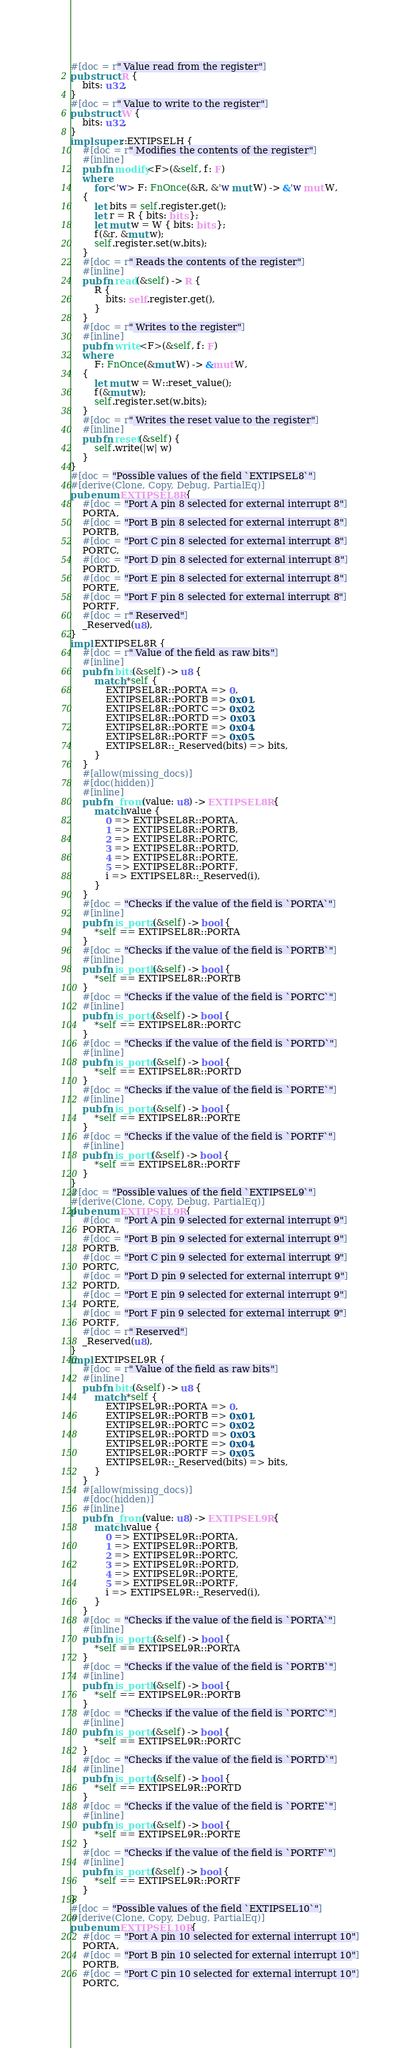Convert code to text. <code><loc_0><loc_0><loc_500><loc_500><_Rust_>#[doc = r" Value read from the register"]
pub struct R {
    bits: u32,
}
#[doc = r" Value to write to the register"]
pub struct W {
    bits: u32,
}
impl super::EXTIPSELH {
    #[doc = r" Modifies the contents of the register"]
    #[inline]
    pub fn modify<F>(&self, f: F)
    where
        for<'w> F: FnOnce(&R, &'w mut W) -> &'w mut W,
    {
        let bits = self.register.get();
        let r = R { bits: bits };
        let mut w = W { bits: bits };
        f(&r, &mut w);
        self.register.set(w.bits);
    }
    #[doc = r" Reads the contents of the register"]
    #[inline]
    pub fn read(&self) -> R {
        R {
            bits: self.register.get(),
        }
    }
    #[doc = r" Writes to the register"]
    #[inline]
    pub fn write<F>(&self, f: F)
    where
        F: FnOnce(&mut W) -> &mut W,
    {
        let mut w = W::reset_value();
        f(&mut w);
        self.register.set(w.bits);
    }
    #[doc = r" Writes the reset value to the register"]
    #[inline]
    pub fn reset(&self) {
        self.write(|w| w)
    }
}
#[doc = "Possible values of the field `EXTIPSEL8`"]
#[derive(Clone, Copy, Debug, PartialEq)]
pub enum EXTIPSEL8R {
    #[doc = "Port A pin 8 selected for external interrupt 8"]
    PORTA,
    #[doc = "Port B pin 8 selected for external interrupt 8"]
    PORTB,
    #[doc = "Port C pin 8 selected for external interrupt 8"]
    PORTC,
    #[doc = "Port D pin 8 selected for external interrupt 8"]
    PORTD,
    #[doc = "Port E pin 8 selected for external interrupt 8"]
    PORTE,
    #[doc = "Port F pin 8 selected for external interrupt 8"]
    PORTF,
    #[doc = r" Reserved"]
    _Reserved(u8),
}
impl EXTIPSEL8R {
    #[doc = r" Value of the field as raw bits"]
    #[inline]
    pub fn bits(&self) -> u8 {
        match *self {
            EXTIPSEL8R::PORTA => 0,
            EXTIPSEL8R::PORTB => 0x01,
            EXTIPSEL8R::PORTC => 0x02,
            EXTIPSEL8R::PORTD => 0x03,
            EXTIPSEL8R::PORTE => 0x04,
            EXTIPSEL8R::PORTF => 0x05,
            EXTIPSEL8R::_Reserved(bits) => bits,
        }
    }
    #[allow(missing_docs)]
    #[doc(hidden)]
    #[inline]
    pub fn _from(value: u8) -> EXTIPSEL8R {
        match value {
            0 => EXTIPSEL8R::PORTA,
            1 => EXTIPSEL8R::PORTB,
            2 => EXTIPSEL8R::PORTC,
            3 => EXTIPSEL8R::PORTD,
            4 => EXTIPSEL8R::PORTE,
            5 => EXTIPSEL8R::PORTF,
            i => EXTIPSEL8R::_Reserved(i),
        }
    }
    #[doc = "Checks if the value of the field is `PORTA`"]
    #[inline]
    pub fn is_porta(&self) -> bool {
        *self == EXTIPSEL8R::PORTA
    }
    #[doc = "Checks if the value of the field is `PORTB`"]
    #[inline]
    pub fn is_portb(&self) -> bool {
        *self == EXTIPSEL8R::PORTB
    }
    #[doc = "Checks if the value of the field is `PORTC`"]
    #[inline]
    pub fn is_portc(&self) -> bool {
        *self == EXTIPSEL8R::PORTC
    }
    #[doc = "Checks if the value of the field is `PORTD`"]
    #[inline]
    pub fn is_portd(&self) -> bool {
        *self == EXTIPSEL8R::PORTD
    }
    #[doc = "Checks if the value of the field is `PORTE`"]
    #[inline]
    pub fn is_porte(&self) -> bool {
        *self == EXTIPSEL8R::PORTE
    }
    #[doc = "Checks if the value of the field is `PORTF`"]
    #[inline]
    pub fn is_portf(&self) -> bool {
        *self == EXTIPSEL8R::PORTF
    }
}
#[doc = "Possible values of the field `EXTIPSEL9`"]
#[derive(Clone, Copy, Debug, PartialEq)]
pub enum EXTIPSEL9R {
    #[doc = "Port A pin 9 selected for external interrupt 9"]
    PORTA,
    #[doc = "Port B pin 9 selected for external interrupt 9"]
    PORTB,
    #[doc = "Port C pin 9 selected for external interrupt 9"]
    PORTC,
    #[doc = "Port D pin 9 selected for external interrupt 9"]
    PORTD,
    #[doc = "Port E pin 9 selected for external interrupt 9"]
    PORTE,
    #[doc = "Port F pin 9 selected for external interrupt 9"]
    PORTF,
    #[doc = r" Reserved"]
    _Reserved(u8),
}
impl EXTIPSEL9R {
    #[doc = r" Value of the field as raw bits"]
    #[inline]
    pub fn bits(&self) -> u8 {
        match *self {
            EXTIPSEL9R::PORTA => 0,
            EXTIPSEL9R::PORTB => 0x01,
            EXTIPSEL9R::PORTC => 0x02,
            EXTIPSEL9R::PORTD => 0x03,
            EXTIPSEL9R::PORTE => 0x04,
            EXTIPSEL9R::PORTF => 0x05,
            EXTIPSEL9R::_Reserved(bits) => bits,
        }
    }
    #[allow(missing_docs)]
    #[doc(hidden)]
    #[inline]
    pub fn _from(value: u8) -> EXTIPSEL9R {
        match value {
            0 => EXTIPSEL9R::PORTA,
            1 => EXTIPSEL9R::PORTB,
            2 => EXTIPSEL9R::PORTC,
            3 => EXTIPSEL9R::PORTD,
            4 => EXTIPSEL9R::PORTE,
            5 => EXTIPSEL9R::PORTF,
            i => EXTIPSEL9R::_Reserved(i),
        }
    }
    #[doc = "Checks if the value of the field is `PORTA`"]
    #[inline]
    pub fn is_porta(&self) -> bool {
        *self == EXTIPSEL9R::PORTA
    }
    #[doc = "Checks if the value of the field is `PORTB`"]
    #[inline]
    pub fn is_portb(&self) -> bool {
        *self == EXTIPSEL9R::PORTB
    }
    #[doc = "Checks if the value of the field is `PORTC`"]
    #[inline]
    pub fn is_portc(&self) -> bool {
        *self == EXTIPSEL9R::PORTC
    }
    #[doc = "Checks if the value of the field is `PORTD`"]
    #[inline]
    pub fn is_portd(&self) -> bool {
        *self == EXTIPSEL9R::PORTD
    }
    #[doc = "Checks if the value of the field is `PORTE`"]
    #[inline]
    pub fn is_porte(&self) -> bool {
        *self == EXTIPSEL9R::PORTE
    }
    #[doc = "Checks if the value of the field is `PORTF`"]
    #[inline]
    pub fn is_portf(&self) -> bool {
        *self == EXTIPSEL9R::PORTF
    }
}
#[doc = "Possible values of the field `EXTIPSEL10`"]
#[derive(Clone, Copy, Debug, PartialEq)]
pub enum EXTIPSEL10R {
    #[doc = "Port A pin 10 selected for external interrupt 10"]
    PORTA,
    #[doc = "Port B pin 10 selected for external interrupt 10"]
    PORTB,
    #[doc = "Port C pin 10 selected for external interrupt 10"]
    PORTC,</code> 